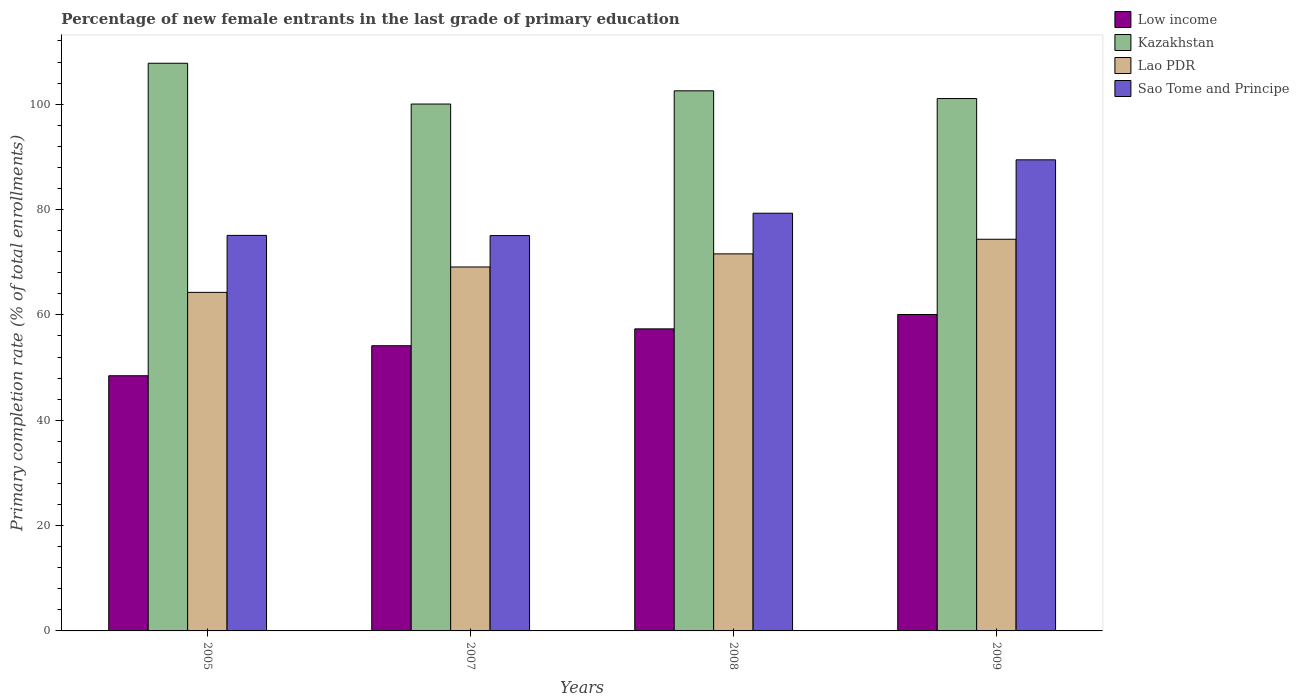How many different coloured bars are there?
Keep it short and to the point. 4. How many groups of bars are there?
Keep it short and to the point. 4. Are the number of bars per tick equal to the number of legend labels?
Make the answer very short. Yes. How many bars are there on the 3rd tick from the left?
Provide a succinct answer. 4. How many bars are there on the 1st tick from the right?
Provide a short and direct response. 4. What is the percentage of new female entrants in Kazakhstan in 2009?
Keep it short and to the point. 101.07. Across all years, what is the maximum percentage of new female entrants in Kazakhstan?
Provide a succinct answer. 107.77. Across all years, what is the minimum percentage of new female entrants in Low income?
Your answer should be compact. 48.44. In which year was the percentage of new female entrants in Sao Tome and Principe maximum?
Your answer should be compact. 2009. In which year was the percentage of new female entrants in Lao PDR minimum?
Ensure brevity in your answer.  2005. What is the total percentage of new female entrants in Kazakhstan in the graph?
Keep it short and to the point. 411.4. What is the difference between the percentage of new female entrants in Lao PDR in 2005 and that in 2009?
Keep it short and to the point. -10.08. What is the difference between the percentage of new female entrants in Lao PDR in 2007 and the percentage of new female entrants in Sao Tome and Principe in 2009?
Ensure brevity in your answer.  -20.34. What is the average percentage of new female entrants in Low income per year?
Give a very brief answer. 55. In the year 2005, what is the difference between the percentage of new female entrants in Lao PDR and percentage of new female entrants in Kazakhstan?
Keep it short and to the point. -43.5. In how many years, is the percentage of new female entrants in Kazakhstan greater than 8 %?
Your response must be concise. 4. What is the ratio of the percentage of new female entrants in Low income in 2005 to that in 2009?
Provide a short and direct response. 0.81. Is the percentage of new female entrants in Sao Tome and Principe in 2005 less than that in 2008?
Ensure brevity in your answer.  Yes. What is the difference between the highest and the second highest percentage of new female entrants in Low income?
Offer a terse response. 2.72. What is the difference between the highest and the lowest percentage of new female entrants in Kazakhstan?
Provide a short and direct response. 7.74. In how many years, is the percentage of new female entrants in Kazakhstan greater than the average percentage of new female entrants in Kazakhstan taken over all years?
Ensure brevity in your answer.  1. Is it the case that in every year, the sum of the percentage of new female entrants in Kazakhstan and percentage of new female entrants in Lao PDR is greater than the sum of percentage of new female entrants in Sao Tome and Principe and percentage of new female entrants in Low income?
Give a very brief answer. No. What does the 3rd bar from the left in 2007 represents?
Offer a terse response. Lao PDR. Is it the case that in every year, the sum of the percentage of new female entrants in Sao Tome and Principe and percentage of new female entrants in Lao PDR is greater than the percentage of new female entrants in Low income?
Make the answer very short. Yes. How many bars are there?
Provide a succinct answer. 16. Are all the bars in the graph horizontal?
Your answer should be compact. No. What is the difference between two consecutive major ticks on the Y-axis?
Offer a terse response. 20. Are the values on the major ticks of Y-axis written in scientific E-notation?
Provide a short and direct response. No. Does the graph contain grids?
Your answer should be very brief. No. Where does the legend appear in the graph?
Ensure brevity in your answer.  Top right. How are the legend labels stacked?
Provide a short and direct response. Vertical. What is the title of the graph?
Offer a terse response. Percentage of new female entrants in the last grade of primary education. What is the label or title of the Y-axis?
Provide a short and direct response. Primary completion rate (% of total enrollments). What is the Primary completion rate (% of total enrollments) of Low income in 2005?
Make the answer very short. 48.44. What is the Primary completion rate (% of total enrollments) in Kazakhstan in 2005?
Make the answer very short. 107.77. What is the Primary completion rate (% of total enrollments) of Lao PDR in 2005?
Make the answer very short. 64.27. What is the Primary completion rate (% of total enrollments) in Sao Tome and Principe in 2005?
Make the answer very short. 75.09. What is the Primary completion rate (% of total enrollments) in Low income in 2007?
Provide a succinct answer. 54.14. What is the Primary completion rate (% of total enrollments) in Kazakhstan in 2007?
Keep it short and to the point. 100.03. What is the Primary completion rate (% of total enrollments) of Lao PDR in 2007?
Offer a very short reply. 69.09. What is the Primary completion rate (% of total enrollments) of Sao Tome and Principe in 2007?
Offer a very short reply. 75.05. What is the Primary completion rate (% of total enrollments) in Low income in 2008?
Provide a succinct answer. 57.34. What is the Primary completion rate (% of total enrollments) in Kazakhstan in 2008?
Provide a short and direct response. 102.54. What is the Primary completion rate (% of total enrollments) in Lao PDR in 2008?
Make the answer very short. 71.58. What is the Primary completion rate (% of total enrollments) in Sao Tome and Principe in 2008?
Your answer should be compact. 79.3. What is the Primary completion rate (% of total enrollments) in Low income in 2009?
Offer a terse response. 60.07. What is the Primary completion rate (% of total enrollments) in Kazakhstan in 2009?
Your response must be concise. 101.07. What is the Primary completion rate (% of total enrollments) in Lao PDR in 2009?
Your response must be concise. 74.35. What is the Primary completion rate (% of total enrollments) of Sao Tome and Principe in 2009?
Provide a succinct answer. 89.44. Across all years, what is the maximum Primary completion rate (% of total enrollments) in Low income?
Provide a short and direct response. 60.07. Across all years, what is the maximum Primary completion rate (% of total enrollments) in Kazakhstan?
Your response must be concise. 107.77. Across all years, what is the maximum Primary completion rate (% of total enrollments) of Lao PDR?
Ensure brevity in your answer.  74.35. Across all years, what is the maximum Primary completion rate (% of total enrollments) of Sao Tome and Principe?
Your answer should be very brief. 89.44. Across all years, what is the minimum Primary completion rate (% of total enrollments) in Low income?
Provide a short and direct response. 48.44. Across all years, what is the minimum Primary completion rate (% of total enrollments) in Kazakhstan?
Offer a terse response. 100.03. Across all years, what is the minimum Primary completion rate (% of total enrollments) of Lao PDR?
Ensure brevity in your answer.  64.27. Across all years, what is the minimum Primary completion rate (% of total enrollments) in Sao Tome and Principe?
Keep it short and to the point. 75.05. What is the total Primary completion rate (% of total enrollments) in Low income in the graph?
Your answer should be compact. 220. What is the total Primary completion rate (% of total enrollments) in Kazakhstan in the graph?
Ensure brevity in your answer.  411.4. What is the total Primary completion rate (% of total enrollments) in Lao PDR in the graph?
Make the answer very short. 279.3. What is the total Primary completion rate (% of total enrollments) of Sao Tome and Principe in the graph?
Make the answer very short. 318.88. What is the difference between the Primary completion rate (% of total enrollments) in Low income in 2005 and that in 2007?
Provide a succinct answer. -5.7. What is the difference between the Primary completion rate (% of total enrollments) of Kazakhstan in 2005 and that in 2007?
Offer a terse response. 7.74. What is the difference between the Primary completion rate (% of total enrollments) of Lao PDR in 2005 and that in 2007?
Provide a succinct answer. -4.82. What is the difference between the Primary completion rate (% of total enrollments) in Sao Tome and Principe in 2005 and that in 2007?
Offer a very short reply. 0.04. What is the difference between the Primary completion rate (% of total enrollments) in Low income in 2005 and that in 2008?
Make the answer very short. -8.9. What is the difference between the Primary completion rate (% of total enrollments) in Kazakhstan in 2005 and that in 2008?
Provide a short and direct response. 5.23. What is the difference between the Primary completion rate (% of total enrollments) in Lao PDR in 2005 and that in 2008?
Offer a terse response. -7.31. What is the difference between the Primary completion rate (% of total enrollments) of Sao Tome and Principe in 2005 and that in 2008?
Your response must be concise. -4.2. What is the difference between the Primary completion rate (% of total enrollments) of Low income in 2005 and that in 2009?
Make the answer very short. -11.62. What is the difference between the Primary completion rate (% of total enrollments) in Kazakhstan in 2005 and that in 2009?
Your answer should be compact. 6.7. What is the difference between the Primary completion rate (% of total enrollments) of Lao PDR in 2005 and that in 2009?
Provide a short and direct response. -10.08. What is the difference between the Primary completion rate (% of total enrollments) of Sao Tome and Principe in 2005 and that in 2009?
Offer a terse response. -14.34. What is the difference between the Primary completion rate (% of total enrollments) of Low income in 2007 and that in 2008?
Provide a short and direct response. -3.2. What is the difference between the Primary completion rate (% of total enrollments) in Kazakhstan in 2007 and that in 2008?
Keep it short and to the point. -2.51. What is the difference between the Primary completion rate (% of total enrollments) in Lao PDR in 2007 and that in 2008?
Keep it short and to the point. -2.49. What is the difference between the Primary completion rate (% of total enrollments) of Sao Tome and Principe in 2007 and that in 2008?
Your answer should be very brief. -4.24. What is the difference between the Primary completion rate (% of total enrollments) of Low income in 2007 and that in 2009?
Offer a very short reply. -5.93. What is the difference between the Primary completion rate (% of total enrollments) in Kazakhstan in 2007 and that in 2009?
Your response must be concise. -1.04. What is the difference between the Primary completion rate (% of total enrollments) in Lao PDR in 2007 and that in 2009?
Make the answer very short. -5.26. What is the difference between the Primary completion rate (% of total enrollments) in Sao Tome and Principe in 2007 and that in 2009?
Your answer should be compact. -14.38. What is the difference between the Primary completion rate (% of total enrollments) of Low income in 2008 and that in 2009?
Offer a very short reply. -2.72. What is the difference between the Primary completion rate (% of total enrollments) of Kazakhstan in 2008 and that in 2009?
Your answer should be very brief. 1.47. What is the difference between the Primary completion rate (% of total enrollments) in Lao PDR in 2008 and that in 2009?
Provide a short and direct response. -2.77. What is the difference between the Primary completion rate (% of total enrollments) in Sao Tome and Principe in 2008 and that in 2009?
Make the answer very short. -10.14. What is the difference between the Primary completion rate (% of total enrollments) of Low income in 2005 and the Primary completion rate (% of total enrollments) of Kazakhstan in 2007?
Provide a succinct answer. -51.58. What is the difference between the Primary completion rate (% of total enrollments) in Low income in 2005 and the Primary completion rate (% of total enrollments) in Lao PDR in 2007?
Give a very brief answer. -20.65. What is the difference between the Primary completion rate (% of total enrollments) of Low income in 2005 and the Primary completion rate (% of total enrollments) of Sao Tome and Principe in 2007?
Make the answer very short. -26.61. What is the difference between the Primary completion rate (% of total enrollments) in Kazakhstan in 2005 and the Primary completion rate (% of total enrollments) in Lao PDR in 2007?
Keep it short and to the point. 38.67. What is the difference between the Primary completion rate (% of total enrollments) in Kazakhstan in 2005 and the Primary completion rate (% of total enrollments) in Sao Tome and Principe in 2007?
Offer a very short reply. 32.72. What is the difference between the Primary completion rate (% of total enrollments) of Lao PDR in 2005 and the Primary completion rate (% of total enrollments) of Sao Tome and Principe in 2007?
Provide a succinct answer. -10.78. What is the difference between the Primary completion rate (% of total enrollments) in Low income in 2005 and the Primary completion rate (% of total enrollments) in Kazakhstan in 2008?
Provide a short and direct response. -54.09. What is the difference between the Primary completion rate (% of total enrollments) of Low income in 2005 and the Primary completion rate (% of total enrollments) of Lao PDR in 2008?
Your response must be concise. -23.14. What is the difference between the Primary completion rate (% of total enrollments) in Low income in 2005 and the Primary completion rate (% of total enrollments) in Sao Tome and Principe in 2008?
Keep it short and to the point. -30.85. What is the difference between the Primary completion rate (% of total enrollments) of Kazakhstan in 2005 and the Primary completion rate (% of total enrollments) of Lao PDR in 2008?
Provide a succinct answer. 36.19. What is the difference between the Primary completion rate (% of total enrollments) in Kazakhstan in 2005 and the Primary completion rate (% of total enrollments) in Sao Tome and Principe in 2008?
Your answer should be compact. 28.47. What is the difference between the Primary completion rate (% of total enrollments) of Lao PDR in 2005 and the Primary completion rate (% of total enrollments) of Sao Tome and Principe in 2008?
Offer a very short reply. -15.02. What is the difference between the Primary completion rate (% of total enrollments) of Low income in 2005 and the Primary completion rate (% of total enrollments) of Kazakhstan in 2009?
Your answer should be very brief. -52.63. What is the difference between the Primary completion rate (% of total enrollments) in Low income in 2005 and the Primary completion rate (% of total enrollments) in Lao PDR in 2009?
Provide a short and direct response. -25.91. What is the difference between the Primary completion rate (% of total enrollments) in Low income in 2005 and the Primary completion rate (% of total enrollments) in Sao Tome and Principe in 2009?
Give a very brief answer. -40.99. What is the difference between the Primary completion rate (% of total enrollments) of Kazakhstan in 2005 and the Primary completion rate (% of total enrollments) of Lao PDR in 2009?
Give a very brief answer. 33.41. What is the difference between the Primary completion rate (% of total enrollments) of Kazakhstan in 2005 and the Primary completion rate (% of total enrollments) of Sao Tome and Principe in 2009?
Make the answer very short. 18.33. What is the difference between the Primary completion rate (% of total enrollments) of Lao PDR in 2005 and the Primary completion rate (% of total enrollments) of Sao Tome and Principe in 2009?
Your answer should be very brief. -25.16. What is the difference between the Primary completion rate (% of total enrollments) of Low income in 2007 and the Primary completion rate (% of total enrollments) of Kazakhstan in 2008?
Offer a terse response. -48.39. What is the difference between the Primary completion rate (% of total enrollments) of Low income in 2007 and the Primary completion rate (% of total enrollments) of Lao PDR in 2008?
Provide a short and direct response. -17.44. What is the difference between the Primary completion rate (% of total enrollments) in Low income in 2007 and the Primary completion rate (% of total enrollments) in Sao Tome and Principe in 2008?
Give a very brief answer. -25.15. What is the difference between the Primary completion rate (% of total enrollments) of Kazakhstan in 2007 and the Primary completion rate (% of total enrollments) of Lao PDR in 2008?
Make the answer very short. 28.44. What is the difference between the Primary completion rate (% of total enrollments) of Kazakhstan in 2007 and the Primary completion rate (% of total enrollments) of Sao Tome and Principe in 2008?
Ensure brevity in your answer.  20.73. What is the difference between the Primary completion rate (% of total enrollments) in Lao PDR in 2007 and the Primary completion rate (% of total enrollments) in Sao Tome and Principe in 2008?
Ensure brevity in your answer.  -10.2. What is the difference between the Primary completion rate (% of total enrollments) of Low income in 2007 and the Primary completion rate (% of total enrollments) of Kazakhstan in 2009?
Your response must be concise. -46.93. What is the difference between the Primary completion rate (% of total enrollments) of Low income in 2007 and the Primary completion rate (% of total enrollments) of Lao PDR in 2009?
Your answer should be compact. -20.21. What is the difference between the Primary completion rate (% of total enrollments) of Low income in 2007 and the Primary completion rate (% of total enrollments) of Sao Tome and Principe in 2009?
Your answer should be very brief. -35.29. What is the difference between the Primary completion rate (% of total enrollments) in Kazakhstan in 2007 and the Primary completion rate (% of total enrollments) in Lao PDR in 2009?
Make the answer very short. 25.67. What is the difference between the Primary completion rate (% of total enrollments) of Kazakhstan in 2007 and the Primary completion rate (% of total enrollments) of Sao Tome and Principe in 2009?
Offer a very short reply. 10.59. What is the difference between the Primary completion rate (% of total enrollments) of Lao PDR in 2007 and the Primary completion rate (% of total enrollments) of Sao Tome and Principe in 2009?
Keep it short and to the point. -20.34. What is the difference between the Primary completion rate (% of total enrollments) in Low income in 2008 and the Primary completion rate (% of total enrollments) in Kazakhstan in 2009?
Provide a succinct answer. -43.72. What is the difference between the Primary completion rate (% of total enrollments) of Low income in 2008 and the Primary completion rate (% of total enrollments) of Lao PDR in 2009?
Make the answer very short. -17.01. What is the difference between the Primary completion rate (% of total enrollments) in Low income in 2008 and the Primary completion rate (% of total enrollments) in Sao Tome and Principe in 2009?
Provide a short and direct response. -32.09. What is the difference between the Primary completion rate (% of total enrollments) in Kazakhstan in 2008 and the Primary completion rate (% of total enrollments) in Lao PDR in 2009?
Keep it short and to the point. 28.18. What is the difference between the Primary completion rate (% of total enrollments) in Lao PDR in 2008 and the Primary completion rate (% of total enrollments) in Sao Tome and Principe in 2009?
Your answer should be compact. -17.85. What is the average Primary completion rate (% of total enrollments) in Low income per year?
Your response must be concise. 55. What is the average Primary completion rate (% of total enrollments) of Kazakhstan per year?
Provide a short and direct response. 102.85. What is the average Primary completion rate (% of total enrollments) in Lao PDR per year?
Your answer should be compact. 69.83. What is the average Primary completion rate (% of total enrollments) of Sao Tome and Principe per year?
Offer a very short reply. 79.72. In the year 2005, what is the difference between the Primary completion rate (% of total enrollments) of Low income and Primary completion rate (% of total enrollments) of Kazakhstan?
Ensure brevity in your answer.  -59.32. In the year 2005, what is the difference between the Primary completion rate (% of total enrollments) in Low income and Primary completion rate (% of total enrollments) in Lao PDR?
Ensure brevity in your answer.  -15.83. In the year 2005, what is the difference between the Primary completion rate (% of total enrollments) of Low income and Primary completion rate (% of total enrollments) of Sao Tome and Principe?
Make the answer very short. -26.65. In the year 2005, what is the difference between the Primary completion rate (% of total enrollments) in Kazakhstan and Primary completion rate (% of total enrollments) in Lao PDR?
Your answer should be compact. 43.5. In the year 2005, what is the difference between the Primary completion rate (% of total enrollments) in Kazakhstan and Primary completion rate (% of total enrollments) in Sao Tome and Principe?
Ensure brevity in your answer.  32.68. In the year 2005, what is the difference between the Primary completion rate (% of total enrollments) in Lao PDR and Primary completion rate (% of total enrollments) in Sao Tome and Principe?
Your answer should be compact. -10.82. In the year 2007, what is the difference between the Primary completion rate (% of total enrollments) of Low income and Primary completion rate (% of total enrollments) of Kazakhstan?
Provide a succinct answer. -45.88. In the year 2007, what is the difference between the Primary completion rate (% of total enrollments) in Low income and Primary completion rate (% of total enrollments) in Lao PDR?
Offer a terse response. -14.95. In the year 2007, what is the difference between the Primary completion rate (% of total enrollments) in Low income and Primary completion rate (% of total enrollments) in Sao Tome and Principe?
Keep it short and to the point. -20.91. In the year 2007, what is the difference between the Primary completion rate (% of total enrollments) in Kazakhstan and Primary completion rate (% of total enrollments) in Lao PDR?
Make the answer very short. 30.93. In the year 2007, what is the difference between the Primary completion rate (% of total enrollments) in Kazakhstan and Primary completion rate (% of total enrollments) in Sao Tome and Principe?
Provide a short and direct response. 24.97. In the year 2007, what is the difference between the Primary completion rate (% of total enrollments) of Lao PDR and Primary completion rate (% of total enrollments) of Sao Tome and Principe?
Provide a short and direct response. -5.96. In the year 2008, what is the difference between the Primary completion rate (% of total enrollments) in Low income and Primary completion rate (% of total enrollments) in Kazakhstan?
Give a very brief answer. -45.19. In the year 2008, what is the difference between the Primary completion rate (% of total enrollments) in Low income and Primary completion rate (% of total enrollments) in Lao PDR?
Provide a succinct answer. -14.24. In the year 2008, what is the difference between the Primary completion rate (% of total enrollments) of Low income and Primary completion rate (% of total enrollments) of Sao Tome and Principe?
Provide a succinct answer. -21.95. In the year 2008, what is the difference between the Primary completion rate (% of total enrollments) of Kazakhstan and Primary completion rate (% of total enrollments) of Lao PDR?
Offer a terse response. 30.95. In the year 2008, what is the difference between the Primary completion rate (% of total enrollments) of Kazakhstan and Primary completion rate (% of total enrollments) of Sao Tome and Principe?
Your response must be concise. 23.24. In the year 2008, what is the difference between the Primary completion rate (% of total enrollments) in Lao PDR and Primary completion rate (% of total enrollments) in Sao Tome and Principe?
Your answer should be very brief. -7.71. In the year 2009, what is the difference between the Primary completion rate (% of total enrollments) of Low income and Primary completion rate (% of total enrollments) of Kazakhstan?
Your response must be concise. -41. In the year 2009, what is the difference between the Primary completion rate (% of total enrollments) in Low income and Primary completion rate (% of total enrollments) in Lao PDR?
Provide a succinct answer. -14.29. In the year 2009, what is the difference between the Primary completion rate (% of total enrollments) of Low income and Primary completion rate (% of total enrollments) of Sao Tome and Principe?
Your answer should be very brief. -29.37. In the year 2009, what is the difference between the Primary completion rate (% of total enrollments) in Kazakhstan and Primary completion rate (% of total enrollments) in Lao PDR?
Keep it short and to the point. 26.71. In the year 2009, what is the difference between the Primary completion rate (% of total enrollments) in Kazakhstan and Primary completion rate (% of total enrollments) in Sao Tome and Principe?
Make the answer very short. 11.63. In the year 2009, what is the difference between the Primary completion rate (% of total enrollments) in Lao PDR and Primary completion rate (% of total enrollments) in Sao Tome and Principe?
Provide a short and direct response. -15.08. What is the ratio of the Primary completion rate (% of total enrollments) in Low income in 2005 to that in 2007?
Your response must be concise. 0.89. What is the ratio of the Primary completion rate (% of total enrollments) in Kazakhstan in 2005 to that in 2007?
Offer a very short reply. 1.08. What is the ratio of the Primary completion rate (% of total enrollments) of Lao PDR in 2005 to that in 2007?
Ensure brevity in your answer.  0.93. What is the ratio of the Primary completion rate (% of total enrollments) in Low income in 2005 to that in 2008?
Keep it short and to the point. 0.84. What is the ratio of the Primary completion rate (% of total enrollments) of Kazakhstan in 2005 to that in 2008?
Keep it short and to the point. 1.05. What is the ratio of the Primary completion rate (% of total enrollments) of Lao PDR in 2005 to that in 2008?
Ensure brevity in your answer.  0.9. What is the ratio of the Primary completion rate (% of total enrollments) in Sao Tome and Principe in 2005 to that in 2008?
Ensure brevity in your answer.  0.95. What is the ratio of the Primary completion rate (% of total enrollments) of Low income in 2005 to that in 2009?
Offer a very short reply. 0.81. What is the ratio of the Primary completion rate (% of total enrollments) of Kazakhstan in 2005 to that in 2009?
Offer a terse response. 1.07. What is the ratio of the Primary completion rate (% of total enrollments) in Lao PDR in 2005 to that in 2009?
Offer a very short reply. 0.86. What is the ratio of the Primary completion rate (% of total enrollments) of Sao Tome and Principe in 2005 to that in 2009?
Make the answer very short. 0.84. What is the ratio of the Primary completion rate (% of total enrollments) in Low income in 2007 to that in 2008?
Provide a short and direct response. 0.94. What is the ratio of the Primary completion rate (% of total enrollments) in Kazakhstan in 2007 to that in 2008?
Keep it short and to the point. 0.98. What is the ratio of the Primary completion rate (% of total enrollments) in Lao PDR in 2007 to that in 2008?
Make the answer very short. 0.97. What is the ratio of the Primary completion rate (% of total enrollments) of Sao Tome and Principe in 2007 to that in 2008?
Ensure brevity in your answer.  0.95. What is the ratio of the Primary completion rate (% of total enrollments) of Low income in 2007 to that in 2009?
Give a very brief answer. 0.9. What is the ratio of the Primary completion rate (% of total enrollments) in Lao PDR in 2007 to that in 2009?
Ensure brevity in your answer.  0.93. What is the ratio of the Primary completion rate (% of total enrollments) in Sao Tome and Principe in 2007 to that in 2009?
Your answer should be compact. 0.84. What is the ratio of the Primary completion rate (% of total enrollments) of Low income in 2008 to that in 2009?
Offer a very short reply. 0.95. What is the ratio of the Primary completion rate (% of total enrollments) of Kazakhstan in 2008 to that in 2009?
Offer a very short reply. 1.01. What is the ratio of the Primary completion rate (% of total enrollments) in Lao PDR in 2008 to that in 2009?
Ensure brevity in your answer.  0.96. What is the ratio of the Primary completion rate (% of total enrollments) of Sao Tome and Principe in 2008 to that in 2009?
Offer a terse response. 0.89. What is the difference between the highest and the second highest Primary completion rate (% of total enrollments) of Low income?
Provide a short and direct response. 2.72. What is the difference between the highest and the second highest Primary completion rate (% of total enrollments) in Kazakhstan?
Your answer should be very brief. 5.23. What is the difference between the highest and the second highest Primary completion rate (% of total enrollments) in Lao PDR?
Offer a terse response. 2.77. What is the difference between the highest and the second highest Primary completion rate (% of total enrollments) in Sao Tome and Principe?
Your answer should be compact. 10.14. What is the difference between the highest and the lowest Primary completion rate (% of total enrollments) of Low income?
Offer a terse response. 11.62. What is the difference between the highest and the lowest Primary completion rate (% of total enrollments) of Kazakhstan?
Your response must be concise. 7.74. What is the difference between the highest and the lowest Primary completion rate (% of total enrollments) in Lao PDR?
Offer a terse response. 10.08. What is the difference between the highest and the lowest Primary completion rate (% of total enrollments) of Sao Tome and Principe?
Provide a short and direct response. 14.38. 